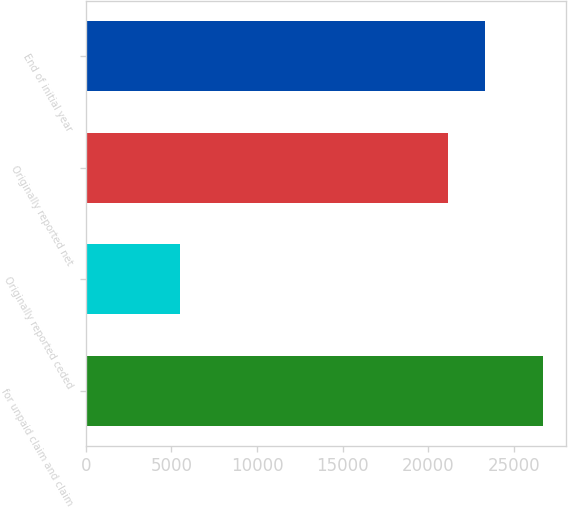Convert chart to OTSL. <chart><loc_0><loc_0><loc_500><loc_500><bar_chart><fcel>for unpaid claim and claim<fcel>Originally reported ceded<fcel>Originally reported net<fcel>End of initial year<nl><fcel>26712<fcel>5524<fcel>21188<fcel>23306.8<nl></chart> 